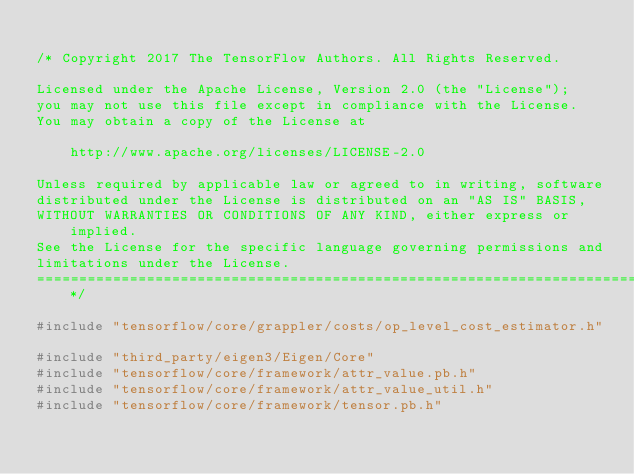<code> <loc_0><loc_0><loc_500><loc_500><_C++_>
/* Copyright 2017 The TensorFlow Authors. All Rights Reserved.

Licensed under the Apache License, Version 2.0 (the "License");
you may not use this file except in compliance with the License.
You may obtain a copy of the License at

    http://www.apache.org/licenses/LICENSE-2.0

Unless required by applicable law or agreed to in writing, software
distributed under the License is distributed on an "AS IS" BASIS,
WITHOUT WARRANTIES OR CONDITIONS OF ANY KIND, either express or implied.
See the License for the specific language governing permissions and
limitations under the License.
==============================================================================*/

#include "tensorflow/core/grappler/costs/op_level_cost_estimator.h"

#include "third_party/eigen3/Eigen/Core"
#include "tensorflow/core/framework/attr_value.pb.h"
#include "tensorflow/core/framework/attr_value_util.h"
#include "tensorflow/core/framework/tensor.pb.h"</code> 